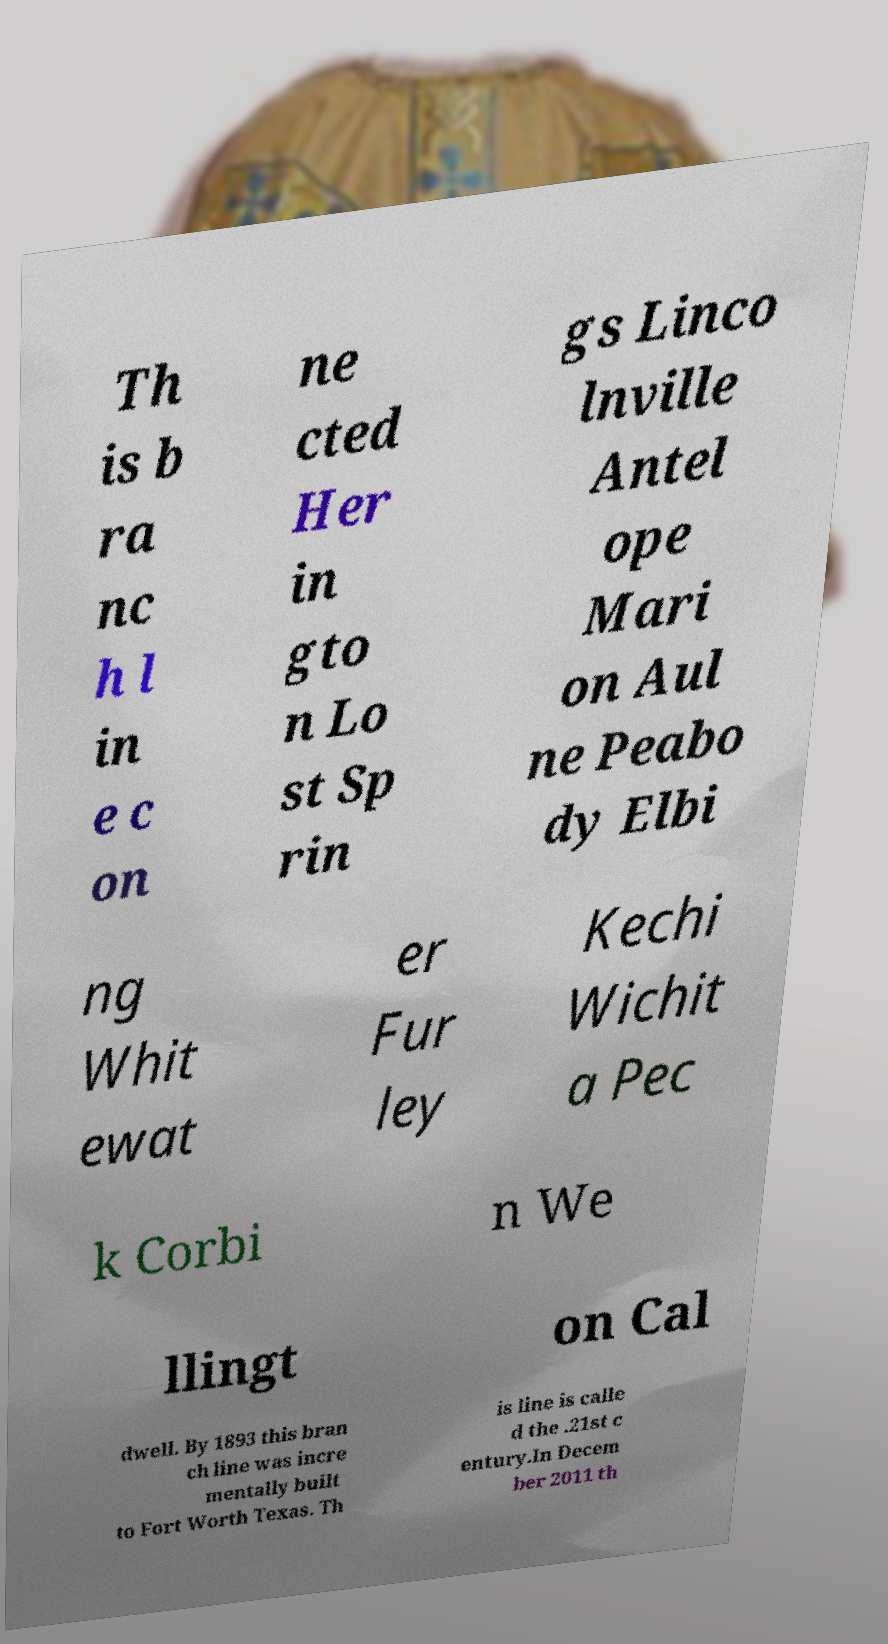There's text embedded in this image that I need extracted. Can you transcribe it verbatim? Th is b ra nc h l in e c on ne cted Her in gto n Lo st Sp rin gs Linco lnville Antel ope Mari on Aul ne Peabo dy Elbi ng Whit ewat er Fur ley Kechi Wichit a Pec k Corbi n We llingt on Cal dwell. By 1893 this bran ch line was incre mentally built to Fort Worth Texas. Th is line is calle d the .21st c entury.In Decem ber 2011 th 